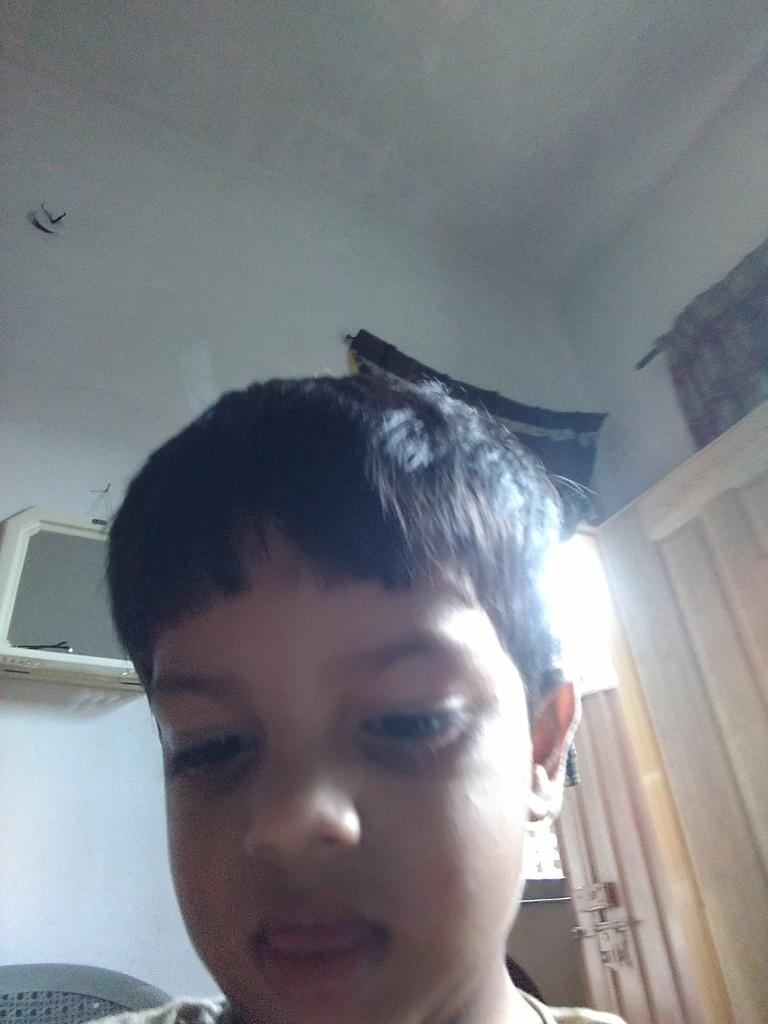Who is present in the image? There is a boy in the image. Where is the boy located? The boy is in a room. What can be seen on the wall in the image? There is a mirror attached to the wall in the image. What is a feature of the room that allows for entry or exit? There is a door in the image. What type of window treatment can be seen in the background of the image? There are objects that look like curtains in the background of the image. What type of snake can be seen slithering on the floor in the image? There is no snake present in the image; it only features a boy in a room with a mirror, a door, and curtains. 